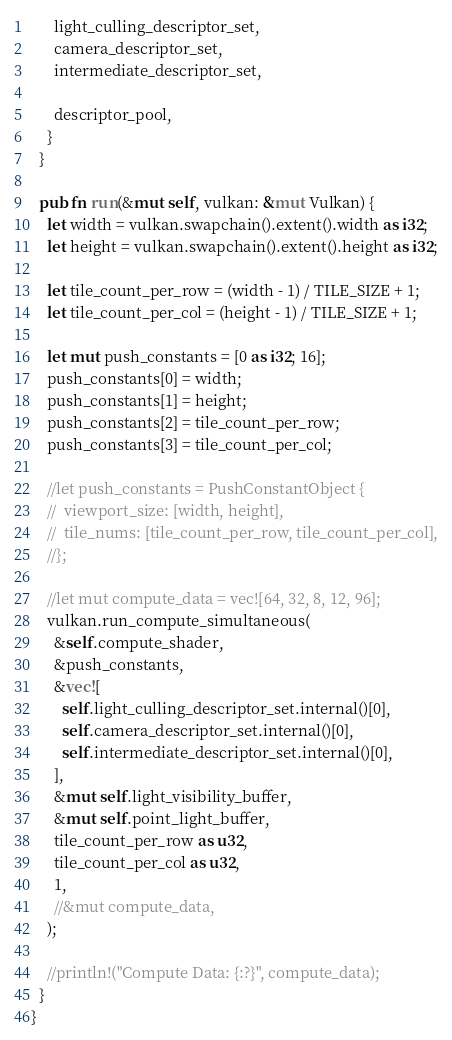<code> <loc_0><loc_0><loc_500><loc_500><_Rust_>      light_culling_descriptor_set,
      camera_descriptor_set,
      intermediate_descriptor_set,

      descriptor_pool,
    }
  }

  pub fn run(&mut self, vulkan: &mut Vulkan) {
    let width = vulkan.swapchain().extent().width as i32;
    let height = vulkan.swapchain().extent().height as i32;

    let tile_count_per_row = (width - 1) / TILE_SIZE + 1;
    let tile_count_per_col = (height - 1) / TILE_SIZE + 1;

    let mut push_constants = [0 as i32; 16];
    push_constants[0] = width;
    push_constants[1] = height;
    push_constants[2] = tile_count_per_row;
    push_constants[3] = tile_count_per_col;

    //let push_constants = PushConstantObject {
    //  viewport_size: [width, height],
    //  tile_nums: [tile_count_per_row, tile_count_per_col],
    //};

    //let mut compute_data = vec![64, 32, 8, 12, 96];
    vulkan.run_compute_simultaneous(
      &self.compute_shader,
      &push_constants,
      &vec![
        self.light_culling_descriptor_set.internal()[0],
        self.camera_descriptor_set.internal()[0],
        self.intermediate_descriptor_set.internal()[0],
      ],
      &mut self.light_visibility_buffer,
      &mut self.point_light_buffer,
      tile_count_per_row as u32,
      tile_count_per_col as u32,
      1,
      //&mut compute_data,
    );

    //println!("Compute Data: {:?}", compute_data);
  }
}
</code> 